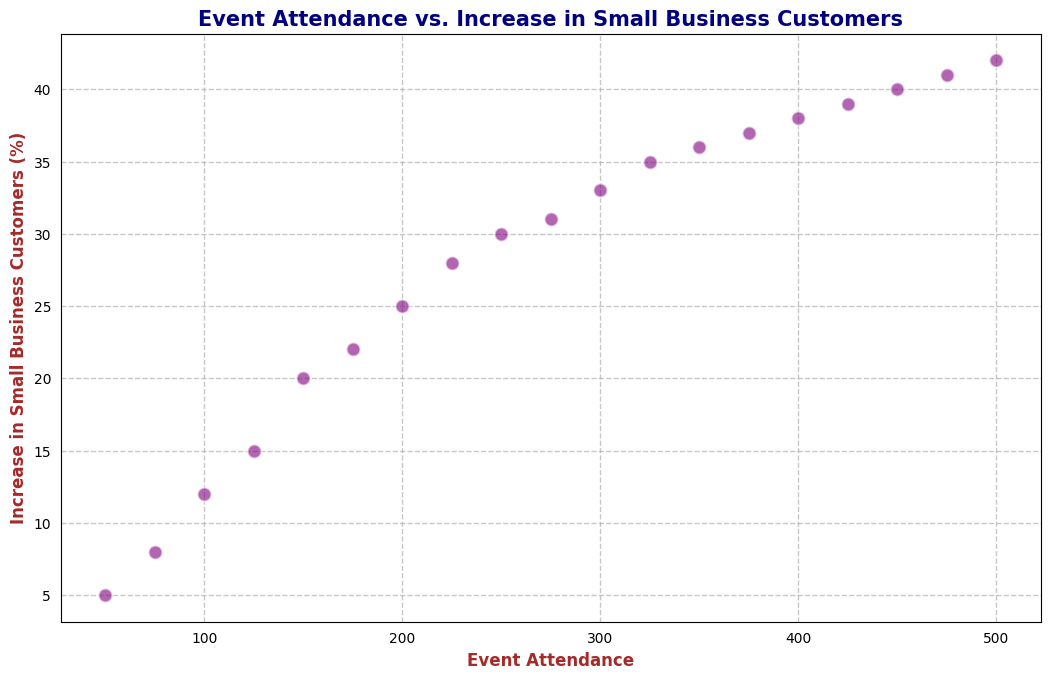What is the increase in small business customers when event attendance is 200? By looking at the scatter plot, locate the point where the x-axis (event attendance) is 200. The corresponding y-value will give you the increase in small business customers.
Answer: 25 Which event attendance value corresponds to an increase of 33% in small business customers? Find the point on the scatter plot where the y-axis (increase in small business customers) is 33. The corresponding x-value gives you the event attendance.
Answer: 300 Is there a visible trend between event attendance and the increase in small business customers? By observing the scatter plot, notice the general direction of the data points. If they tend to rise as event attendance increases, there is a positive trend.
Answer: Yes What is the difference in the increase in small business customers between event attendances of 100 and 200? Find the y-values for event attendances of 100 and 200. Subtract the increase for 100 from the increase for 200.
Answer: 13 Which event attendance category shows the largest increase in small business customers? Look at the scatter plot to find the point with the highest y-value (increase in small business customers). The corresponding x-value indicates the event attendance.
Answer: 500 Is there any event attendance value that corresponds to exactly a 20% increase in small business customers? Look for a point on the scatter plot where the y-value is exactly 20. The x-value at this point will give the event attendance.
Answer: 150 What is the average increase in small business customers for event attendances of 50, 150, and 300? Locate the y-values for event attendances of 50, 150, and 300. Sum these values: 5 + 20 + 33. Divide the total by 3 to get the average.
Answer: 19.33 How does the increase in small business customers change as event attendance goes from 375 to 425? Find the y-values for both 375 and 425 event attendance values. Subtract the increase at 375 from the increase at 425.
Answer: 2 Based on the scatter plot, does a higher event attendance generally result in a higher increase in small business customers? Observe the general positioning and trend of the data points on the scatter plot. If they generally increase in the y-direction as x (event attendance) increases, it indicates a positive correlation.
Answer: Yes Can you identify any outliers or anomalies in the scatter plot? Scan the scatter plot to see if any points fall significantly outside the general trend of other points.
Answer: No 